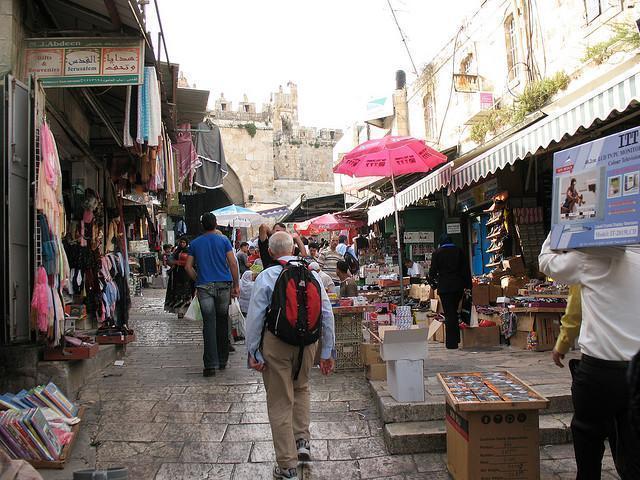What are the people walking through this area looking to do?
Pick the correct solution from the four options below to address the question.
Options: Paint, shop, investigate, race. Shop. 